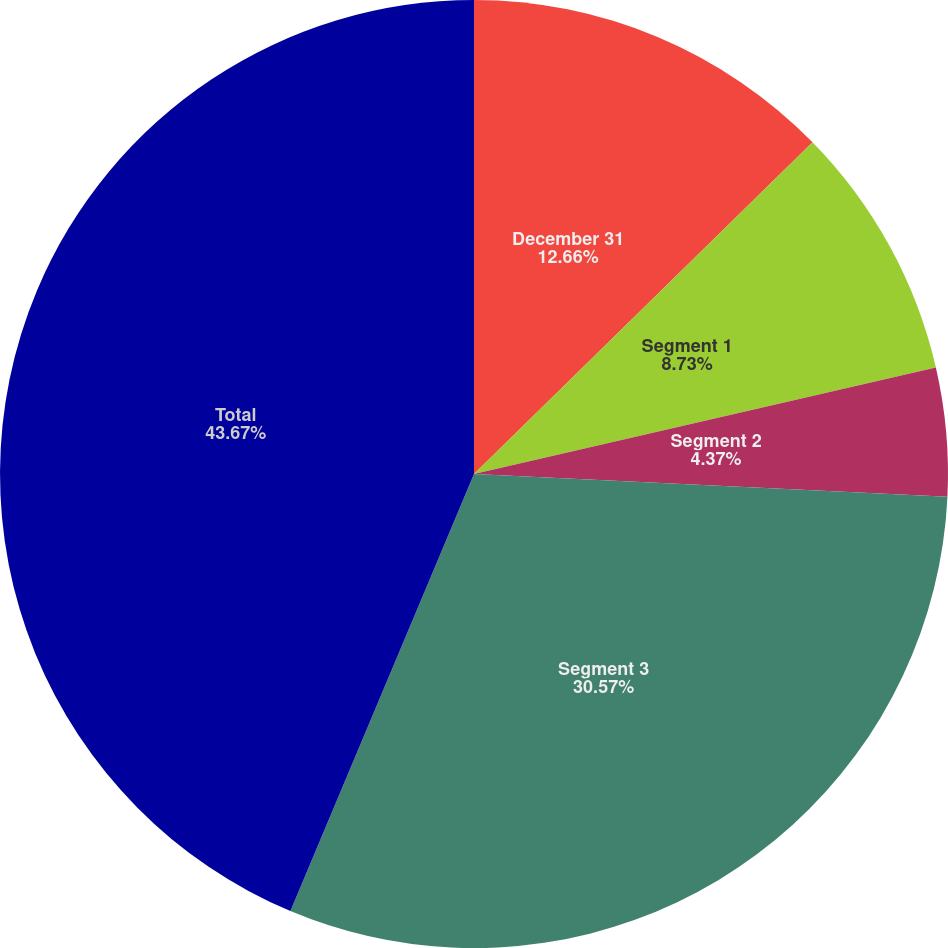<chart> <loc_0><loc_0><loc_500><loc_500><pie_chart><fcel>December 31<fcel>Segment 1<fcel>Segment 2<fcel>Segment 3<fcel>Total<nl><fcel>12.66%<fcel>8.73%<fcel>4.37%<fcel>30.57%<fcel>43.67%<nl></chart> 